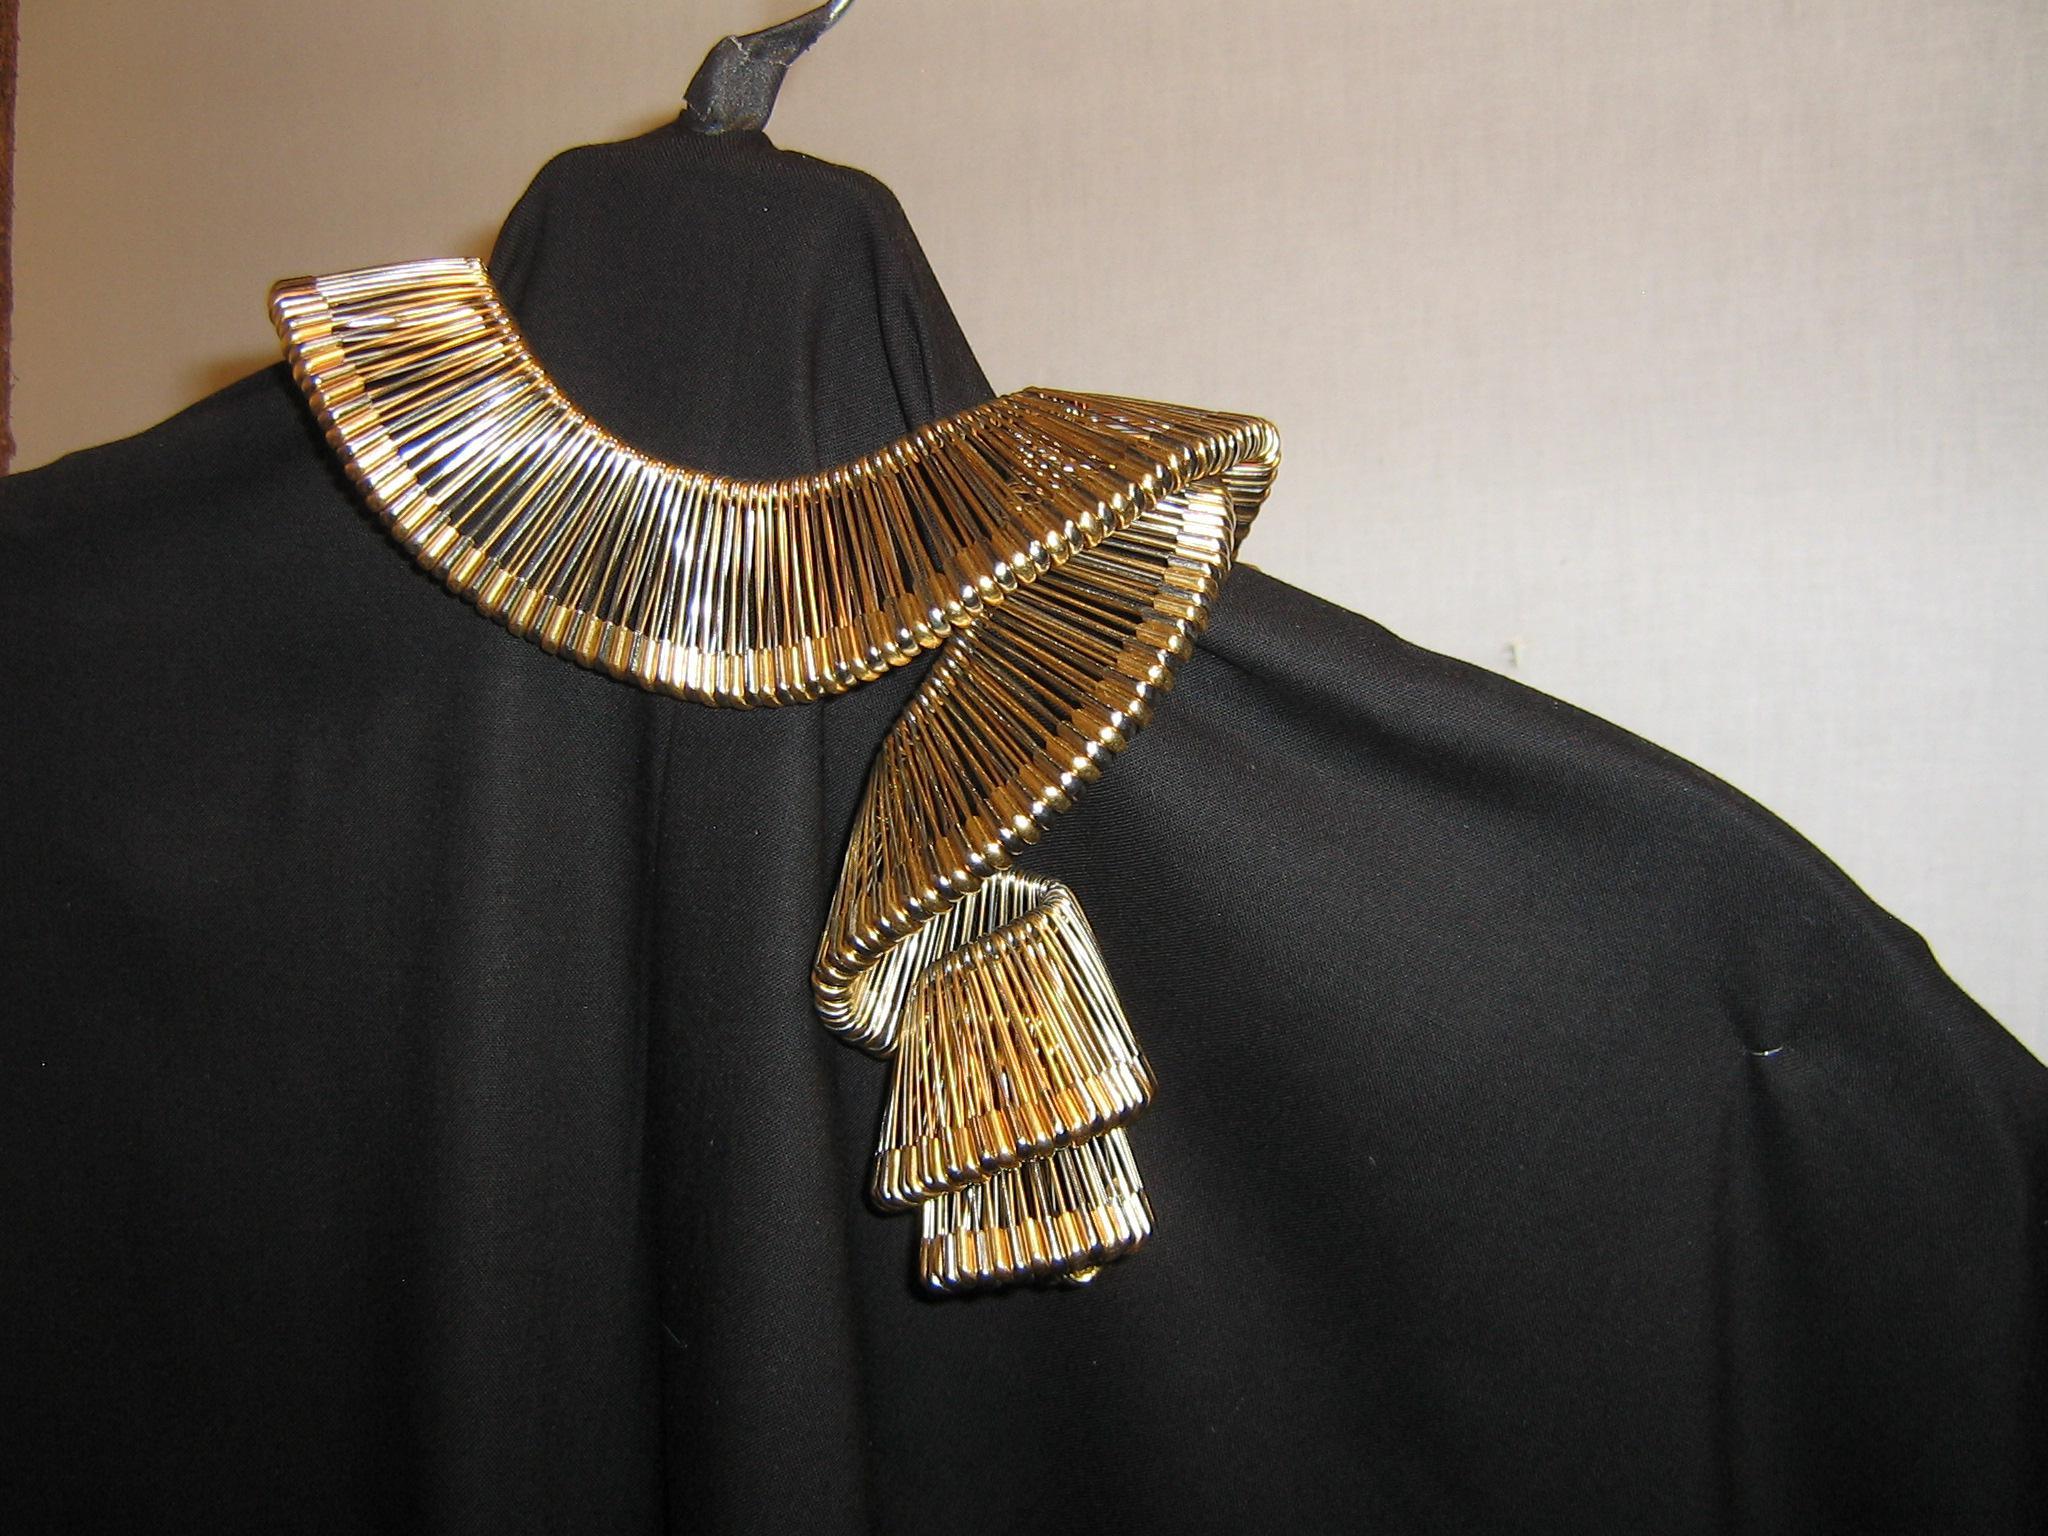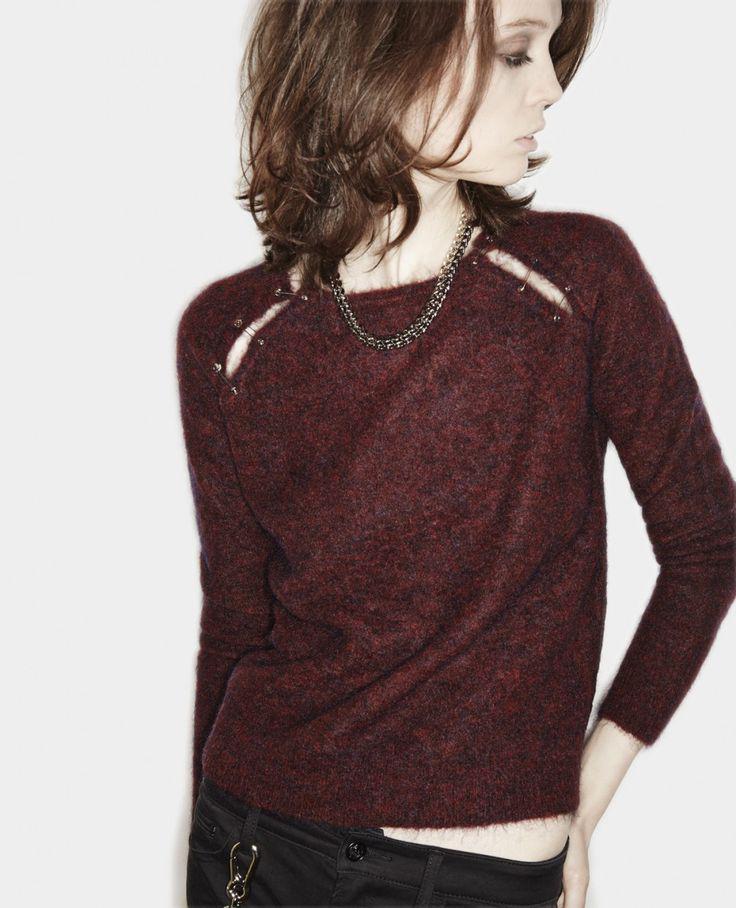The first image is the image on the left, the second image is the image on the right. For the images displayed, is the sentence "An image shows a model wearing a sleeveless black top embellished with safety pins spanning tears in the fabric." factually correct? Answer yes or no. No. The first image is the image on the left, the second image is the image on the right. Evaluate the accuracy of this statement regarding the images: "A woman in the image on the right is wearing a necklace.". Is it true? Answer yes or no. Yes. 